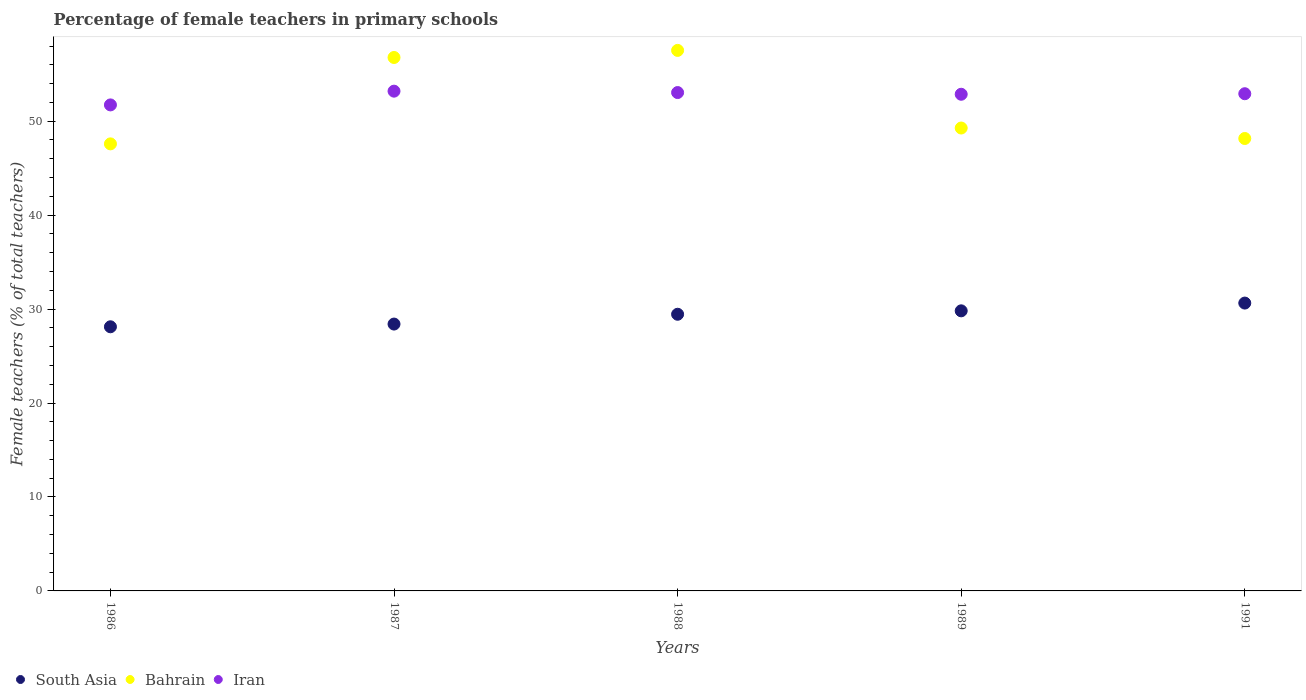How many different coloured dotlines are there?
Keep it short and to the point. 3. What is the percentage of female teachers in Iran in 1988?
Ensure brevity in your answer.  53.05. Across all years, what is the maximum percentage of female teachers in Iran?
Offer a terse response. 53.19. Across all years, what is the minimum percentage of female teachers in Bahrain?
Ensure brevity in your answer.  47.58. In which year was the percentage of female teachers in South Asia maximum?
Your answer should be compact. 1991. In which year was the percentage of female teachers in Bahrain minimum?
Offer a very short reply. 1986. What is the total percentage of female teachers in Iran in the graph?
Ensure brevity in your answer.  263.76. What is the difference between the percentage of female teachers in South Asia in 1986 and that in 1987?
Keep it short and to the point. -0.29. What is the difference between the percentage of female teachers in Bahrain in 1991 and the percentage of female teachers in Iran in 1988?
Offer a very short reply. -4.89. What is the average percentage of female teachers in Iran per year?
Give a very brief answer. 52.75. In the year 1989, what is the difference between the percentage of female teachers in South Asia and percentage of female teachers in Bahrain?
Provide a short and direct response. -19.46. In how many years, is the percentage of female teachers in Bahrain greater than 48 %?
Ensure brevity in your answer.  4. What is the ratio of the percentage of female teachers in Bahrain in 1986 to that in 1991?
Make the answer very short. 0.99. Is the difference between the percentage of female teachers in South Asia in 1987 and 1989 greater than the difference between the percentage of female teachers in Bahrain in 1987 and 1989?
Your answer should be very brief. No. What is the difference between the highest and the second highest percentage of female teachers in South Asia?
Keep it short and to the point. 0.83. What is the difference between the highest and the lowest percentage of female teachers in Bahrain?
Your response must be concise. 9.95. In how many years, is the percentage of female teachers in South Asia greater than the average percentage of female teachers in South Asia taken over all years?
Provide a short and direct response. 3. Does the percentage of female teachers in Iran monotonically increase over the years?
Provide a short and direct response. No. Is the percentage of female teachers in South Asia strictly less than the percentage of female teachers in Bahrain over the years?
Give a very brief answer. Yes. How many years are there in the graph?
Keep it short and to the point. 5. What is the difference between two consecutive major ticks on the Y-axis?
Your answer should be compact. 10. Where does the legend appear in the graph?
Make the answer very short. Bottom left. How many legend labels are there?
Your answer should be very brief. 3. How are the legend labels stacked?
Your response must be concise. Horizontal. What is the title of the graph?
Ensure brevity in your answer.  Percentage of female teachers in primary schools. What is the label or title of the X-axis?
Provide a short and direct response. Years. What is the label or title of the Y-axis?
Give a very brief answer. Female teachers (% of total teachers). What is the Female teachers (% of total teachers) in South Asia in 1986?
Give a very brief answer. 28.11. What is the Female teachers (% of total teachers) in Bahrain in 1986?
Your response must be concise. 47.58. What is the Female teachers (% of total teachers) in Iran in 1986?
Make the answer very short. 51.73. What is the Female teachers (% of total teachers) of South Asia in 1987?
Offer a terse response. 28.4. What is the Female teachers (% of total teachers) of Bahrain in 1987?
Keep it short and to the point. 56.78. What is the Female teachers (% of total teachers) of Iran in 1987?
Keep it short and to the point. 53.19. What is the Female teachers (% of total teachers) of South Asia in 1988?
Your response must be concise. 29.45. What is the Female teachers (% of total teachers) of Bahrain in 1988?
Offer a terse response. 57.53. What is the Female teachers (% of total teachers) of Iran in 1988?
Ensure brevity in your answer.  53.05. What is the Female teachers (% of total teachers) in South Asia in 1989?
Offer a terse response. 29.81. What is the Female teachers (% of total teachers) of Bahrain in 1989?
Give a very brief answer. 49.27. What is the Female teachers (% of total teachers) in Iran in 1989?
Offer a very short reply. 52.86. What is the Female teachers (% of total teachers) of South Asia in 1991?
Give a very brief answer. 30.64. What is the Female teachers (% of total teachers) in Bahrain in 1991?
Ensure brevity in your answer.  48.16. What is the Female teachers (% of total teachers) in Iran in 1991?
Give a very brief answer. 52.92. Across all years, what is the maximum Female teachers (% of total teachers) of South Asia?
Your response must be concise. 30.64. Across all years, what is the maximum Female teachers (% of total teachers) of Bahrain?
Give a very brief answer. 57.53. Across all years, what is the maximum Female teachers (% of total teachers) of Iran?
Your answer should be compact. 53.19. Across all years, what is the minimum Female teachers (% of total teachers) of South Asia?
Give a very brief answer. 28.11. Across all years, what is the minimum Female teachers (% of total teachers) of Bahrain?
Your response must be concise. 47.58. Across all years, what is the minimum Female teachers (% of total teachers) in Iran?
Ensure brevity in your answer.  51.73. What is the total Female teachers (% of total teachers) in South Asia in the graph?
Keep it short and to the point. 146.42. What is the total Female teachers (% of total teachers) of Bahrain in the graph?
Provide a succinct answer. 259.32. What is the total Female teachers (% of total teachers) in Iran in the graph?
Offer a very short reply. 263.76. What is the difference between the Female teachers (% of total teachers) in South Asia in 1986 and that in 1987?
Give a very brief answer. -0.29. What is the difference between the Female teachers (% of total teachers) in Bahrain in 1986 and that in 1987?
Give a very brief answer. -9.2. What is the difference between the Female teachers (% of total teachers) in Iran in 1986 and that in 1987?
Offer a very short reply. -1.46. What is the difference between the Female teachers (% of total teachers) of South Asia in 1986 and that in 1988?
Provide a succinct answer. -1.33. What is the difference between the Female teachers (% of total teachers) in Bahrain in 1986 and that in 1988?
Offer a terse response. -9.95. What is the difference between the Female teachers (% of total teachers) in Iran in 1986 and that in 1988?
Offer a terse response. -1.32. What is the difference between the Female teachers (% of total teachers) in South Asia in 1986 and that in 1989?
Ensure brevity in your answer.  -1.7. What is the difference between the Female teachers (% of total teachers) in Bahrain in 1986 and that in 1989?
Your answer should be compact. -1.69. What is the difference between the Female teachers (% of total teachers) of Iran in 1986 and that in 1989?
Offer a very short reply. -1.13. What is the difference between the Female teachers (% of total teachers) in South Asia in 1986 and that in 1991?
Give a very brief answer. -2.52. What is the difference between the Female teachers (% of total teachers) of Bahrain in 1986 and that in 1991?
Provide a short and direct response. -0.57. What is the difference between the Female teachers (% of total teachers) in Iran in 1986 and that in 1991?
Offer a terse response. -1.19. What is the difference between the Female teachers (% of total teachers) in South Asia in 1987 and that in 1988?
Offer a very short reply. -1.04. What is the difference between the Female teachers (% of total teachers) of Bahrain in 1987 and that in 1988?
Ensure brevity in your answer.  -0.75. What is the difference between the Female teachers (% of total teachers) of Iran in 1987 and that in 1988?
Give a very brief answer. 0.15. What is the difference between the Female teachers (% of total teachers) in South Asia in 1987 and that in 1989?
Ensure brevity in your answer.  -1.41. What is the difference between the Female teachers (% of total teachers) in Bahrain in 1987 and that in 1989?
Ensure brevity in your answer.  7.51. What is the difference between the Female teachers (% of total teachers) of Iran in 1987 and that in 1989?
Keep it short and to the point. 0.33. What is the difference between the Female teachers (% of total teachers) of South Asia in 1987 and that in 1991?
Make the answer very short. -2.23. What is the difference between the Female teachers (% of total teachers) of Bahrain in 1987 and that in 1991?
Keep it short and to the point. 8.62. What is the difference between the Female teachers (% of total teachers) of Iran in 1987 and that in 1991?
Keep it short and to the point. 0.27. What is the difference between the Female teachers (% of total teachers) of South Asia in 1988 and that in 1989?
Your answer should be compact. -0.36. What is the difference between the Female teachers (% of total teachers) in Bahrain in 1988 and that in 1989?
Your answer should be compact. 8.26. What is the difference between the Female teachers (% of total teachers) of Iran in 1988 and that in 1989?
Give a very brief answer. 0.18. What is the difference between the Female teachers (% of total teachers) in South Asia in 1988 and that in 1991?
Give a very brief answer. -1.19. What is the difference between the Female teachers (% of total teachers) of Bahrain in 1988 and that in 1991?
Make the answer very short. 9.38. What is the difference between the Female teachers (% of total teachers) in Iran in 1988 and that in 1991?
Your answer should be very brief. 0.12. What is the difference between the Female teachers (% of total teachers) of South Asia in 1989 and that in 1991?
Keep it short and to the point. -0.83. What is the difference between the Female teachers (% of total teachers) in Bahrain in 1989 and that in 1991?
Provide a short and direct response. 1.11. What is the difference between the Female teachers (% of total teachers) in Iran in 1989 and that in 1991?
Provide a succinct answer. -0.06. What is the difference between the Female teachers (% of total teachers) in South Asia in 1986 and the Female teachers (% of total teachers) in Bahrain in 1987?
Provide a succinct answer. -28.66. What is the difference between the Female teachers (% of total teachers) in South Asia in 1986 and the Female teachers (% of total teachers) in Iran in 1987?
Your answer should be very brief. -25.08. What is the difference between the Female teachers (% of total teachers) of Bahrain in 1986 and the Female teachers (% of total teachers) of Iran in 1987?
Offer a terse response. -5.61. What is the difference between the Female teachers (% of total teachers) of South Asia in 1986 and the Female teachers (% of total teachers) of Bahrain in 1988?
Provide a short and direct response. -29.42. What is the difference between the Female teachers (% of total teachers) of South Asia in 1986 and the Female teachers (% of total teachers) of Iran in 1988?
Provide a succinct answer. -24.93. What is the difference between the Female teachers (% of total teachers) in Bahrain in 1986 and the Female teachers (% of total teachers) in Iran in 1988?
Give a very brief answer. -5.46. What is the difference between the Female teachers (% of total teachers) of South Asia in 1986 and the Female teachers (% of total teachers) of Bahrain in 1989?
Your answer should be compact. -21.16. What is the difference between the Female teachers (% of total teachers) of South Asia in 1986 and the Female teachers (% of total teachers) of Iran in 1989?
Offer a very short reply. -24.75. What is the difference between the Female teachers (% of total teachers) of Bahrain in 1986 and the Female teachers (% of total teachers) of Iran in 1989?
Make the answer very short. -5.28. What is the difference between the Female teachers (% of total teachers) of South Asia in 1986 and the Female teachers (% of total teachers) of Bahrain in 1991?
Provide a succinct answer. -20.04. What is the difference between the Female teachers (% of total teachers) of South Asia in 1986 and the Female teachers (% of total teachers) of Iran in 1991?
Keep it short and to the point. -24.81. What is the difference between the Female teachers (% of total teachers) in Bahrain in 1986 and the Female teachers (% of total teachers) in Iran in 1991?
Your response must be concise. -5.34. What is the difference between the Female teachers (% of total teachers) of South Asia in 1987 and the Female teachers (% of total teachers) of Bahrain in 1988?
Give a very brief answer. -29.13. What is the difference between the Female teachers (% of total teachers) of South Asia in 1987 and the Female teachers (% of total teachers) of Iran in 1988?
Your answer should be compact. -24.64. What is the difference between the Female teachers (% of total teachers) in Bahrain in 1987 and the Female teachers (% of total teachers) in Iran in 1988?
Your response must be concise. 3.73. What is the difference between the Female teachers (% of total teachers) in South Asia in 1987 and the Female teachers (% of total teachers) in Bahrain in 1989?
Keep it short and to the point. -20.87. What is the difference between the Female teachers (% of total teachers) in South Asia in 1987 and the Female teachers (% of total teachers) in Iran in 1989?
Ensure brevity in your answer.  -24.46. What is the difference between the Female teachers (% of total teachers) in Bahrain in 1987 and the Female teachers (% of total teachers) in Iran in 1989?
Your response must be concise. 3.91. What is the difference between the Female teachers (% of total teachers) in South Asia in 1987 and the Female teachers (% of total teachers) in Bahrain in 1991?
Ensure brevity in your answer.  -19.75. What is the difference between the Female teachers (% of total teachers) in South Asia in 1987 and the Female teachers (% of total teachers) in Iran in 1991?
Your answer should be very brief. -24.52. What is the difference between the Female teachers (% of total teachers) of Bahrain in 1987 and the Female teachers (% of total teachers) of Iran in 1991?
Provide a succinct answer. 3.86. What is the difference between the Female teachers (% of total teachers) in South Asia in 1988 and the Female teachers (% of total teachers) in Bahrain in 1989?
Provide a succinct answer. -19.82. What is the difference between the Female teachers (% of total teachers) in South Asia in 1988 and the Female teachers (% of total teachers) in Iran in 1989?
Keep it short and to the point. -23.42. What is the difference between the Female teachers (% of total teachers) in Bahrain in 1988 and the Female teachers (% of total teachers) in Iran in 1989?
Your answer should be compact. 4.67. What is the difference between the Female teachers (% of total teachers) in South Asia in 1988 and the Female teachers (% of total teachers) in Bahrain in 1991?
Give a very brief answer. -18.71. What is the difference between the Female teachers (% of total teachers) of South Asia in 1988 and the Female teachers (% of total teachers) of Iran in 1991?
Your answer should be very brief. -23.47. What is the difference between the Female teachers (% of total teachers) of Bahrain in 1988 and the Female teachers (% of total teachers) of Iran in 1991?
Your answer should be very brief. 4.61. What is the difference between the Female teachers (% of total teachers) of South Asia in 1989 and the Female teachers (% of total teachers) of Bahrain in 1991?
Keep it short and to the point. -18.34. What is the difference between the Female teachers (% of total teachers) in South Asia in 1989 and the Female teachers (% of total teachers) in Iran in 1991?
Offer a very short reply. -23.11. What is the difference between the Female teachers (% of total teachers) of Bahrain in 1989 and the Female teachers (% of total teachers) of Iran in 1991?
Ensure brevity in your answer.  -3.65. What is the average Female teachers (% of total teachers) of South Asia per year?
Provide a succinct answer. 29.28. What is the average Female teachers (% of total teachers) in Bahrain per year?
Offer a terse response. 51.87. What is the average Female teachers (% of total teachers) of Iran per year?
Provide a short and direct response. 52.75. In the year 1986, what is the difference between the Female teachers (% of total teachers) of South Asia and Female teachers (% of total teachers) of Bahrain?
Provide a short and direct response. -19.47. In the year 1986, what is the difference between the Female teachers (% of total teachers) in South Asia and Female teachers (% of total teachers) in Iran?
Your answer should be compact. -23.62. In the year 1986, what is the difference between the Female teachers (% of total teachers) of Bahrain and Female teachers (% of total teachers) of Iran?
Make the answer very short. -4.15. In the year 1987, what is the difference between the Female teachers (% of total teachers) of South Asia and Female teachers (% of total teachers) of Bahrain?
Offer a terse response. -28.37. In the year 1987, what is the difference between the Female teachers (% of total teachers) of South Asia and Female teachers (% of total teachers) of Iran?
Provide a succinct answer. -24.79. In the year 1987, what is the difference between the Female teachers (% of total teachers) of Bahrain and Female teachers (% of total teachers) of Iran?
Your answer should be very brief. 3.58. In the year 1988, what is the difference between the Female teachers (% of total teachers) of South Asia and Female teachers (% of total teachers) of Bahrain?
Provide a succinct answer. -28.09. In the year 1988, what is the difference between the Female teachers (% of total teachers) of South Asia and Female teachers (% of total teachers) of Iran?
Keep it short and to the point. -23.6. In the year 1988, what is the difference between the Female teachers (% of total teachers) of Bahrain and Female teachers (% of total teachers) of Iran?
Ensure brevity in your answer.  4.49. In the year 1989, what is the difference between the Female teachers (% of total teachers) of South Asia and Female teachers (% of total teachers) of Bahrain?
Make the answer very short. -19.46. In the year 1989, what is the difference between the Female teachers (% of total teachers) in South Asia and Female teachers (% of total teachers) in Iran?
Make the answer very short. -23.05. In the year 1989, what is the difference between the Female teachers (% of total teachers) in Bahrain and Female teachers (% of total teachers) in Iran?
Your response must be concise. -3.59. In the year 1991, what is the difference between the Female teachers (% of total teachers) of South Asia and Female teachers (% of total teachers) of Bahrain?
Your answer should be compact. -17.52. In the year 1991, what is the difference between the Female teachers (% of total teachers) of South Asia and Female teachers (% of total teachers) of Iran?
Make the answer very short. -22.28. In the year 1991, what is the difference between the Female teachers (% of total teachers) in Bahrain and Female teachers (% of total teachers) in Iran?
Keep it short and to the point. -4.77. What is the ratio of the Female teachers (% of total teachers) in South Asia in 1986 to that in 1987?
Offer a very short reply. 0.99. What is the ratio of the Female teachers (% of total teachers) in Bahrain in 1986 to that in 1987?
Your answer should be very brief. 0.84. What is the ratio of the Female teachers (% of total teachers) in Iran in 1986 to that in 1987?
Offer a terse response. 0.97. What is the ratio of the Female teachers (% of total teachers) in South Asia in 1986 to that in 1988?
Ensure brevity in your answer.  0.95. What is the ratio of the Female teachers (% of total teachers) of Bahrain in 1986 to that in 1988?
Offer a very short reply. 0.83. What is the ratio of the Female teachers (% of total teachers) of Iran in 1986 to that in 1988?
Your answer should be very brief. 0.98. What is the ratio of the Female teachers (% of total teachers) of South Asia in 1986 to that in 1989?
Offer a terse response. 0.94. What is the ratio of the Female teachers (% of total teachers) in Bahrain in 1986 to that in 1989?
Give a very brief answer. 0.97. What is the ratio of the Female teachers (% of total teachers) of Iran in 1986 to that in 1989?
Your answer should be compact. 0.98. What is the ratio of the Female teachers (% of total teachers) of South Asia in 1986 to that in 1991?
Make the answer very short. 0.92. What is the ratio of the Female teachers (% of total teachers) in Bahrain in 1986 to that in 1991?
Ensure brevity in your answer.  0.99. What is the ratio of the Female teachers (% of total teachers) of Iran in 1986 to that in 1991?
Your answer should be compact. 0.98. What is the ratio of the Female teachers (% of total teachers) of South Asia in 1987 to that in 1988?
Ensure brevity in your answer.  0.96. What is the ratio of the Female teachers (% of total teachers) in Bahrain in 1987 to that in 1988?
Give a very brief answer. 0.99. What is the ratio of the Female teachers (% of total teachers) of Iran in 1987 to that in 1988?
Give a very brief answer. 1. What is the ratio of the Female teachers (% of total teachers) in South Asia in 1987 to that in 1989?
Keep it short and to the point. 0.95. What is the ratio of the Female teachers (% of total teachers) in Bahrain in 1987 to that in 1989?
Provide a short and direct response. 1.15. What is the ratio of the Female teachers (% of total teachers) of South Asia in 1987 to that in 1991?
Make the answer very short. 0.93. What is the ratio of the Female teachers (% of total teachers) in Bahrain in 1987 to that in 1991?
Your answer should be compact. 1.18. What is the ratio of the Female teachers (% of total teachers) of South Asia in 1988 to that in 1989?
Your answer should be compact. 0.99. What is the ratio of the Female teachers (% of total teachers) in Bahrain in 1988 to that in 1989?
Your answer should be compact. 1.17. What is the ratio of the Female teachers (% of total teachers) of South Asia in 1988 to that in 1991?
Offer a very short reply. 0.96. What is the ratio of the Female teachers (% of total teachers) in Bahrain in 1988 to that in 1991?
Offer a terse response. 1.19. What is the ratio of the Female teachers (% of total teachers) of Iran in 1988 to that in 1991?
Provide a short and direct response. 1. What is the ratio of the Female teachers (% of total teachers) of Bahrain in 1989 to that in 1991?
Offer a very short reply. 1.02. What is the ratio of the Female teachers (% of total teachers) in Iran in 1989 to that in 1991?
Your response must be concise. 1. What is the difference between the highest and the second highest Female teachers (% of total teachers) of South Asia?
Your answer should be compact. 0.83. What is the difference between the highest and the second highest Female teachers (% of total teachers) of Bahrain?
Keep it short and to the point. 0.75. What is the difference between the highest and the second highest Female teachers (% of total teachers) in Iran?
Ensure brevity in your answer.  0.15. What is the difference between the highest and the lowest Female teachers (% of total teachers) of South Asia?
Your response must be concise. 2.52. What is the difference between the highest and the lowest Female teachers (% of total teachers) in Bahrain?
Ensure brevity in your answer.  9.95. What is the difference between the highest and the lowest Female teachers (% of total teachers) in Iran?
Offer a very short reply. 1.46. 